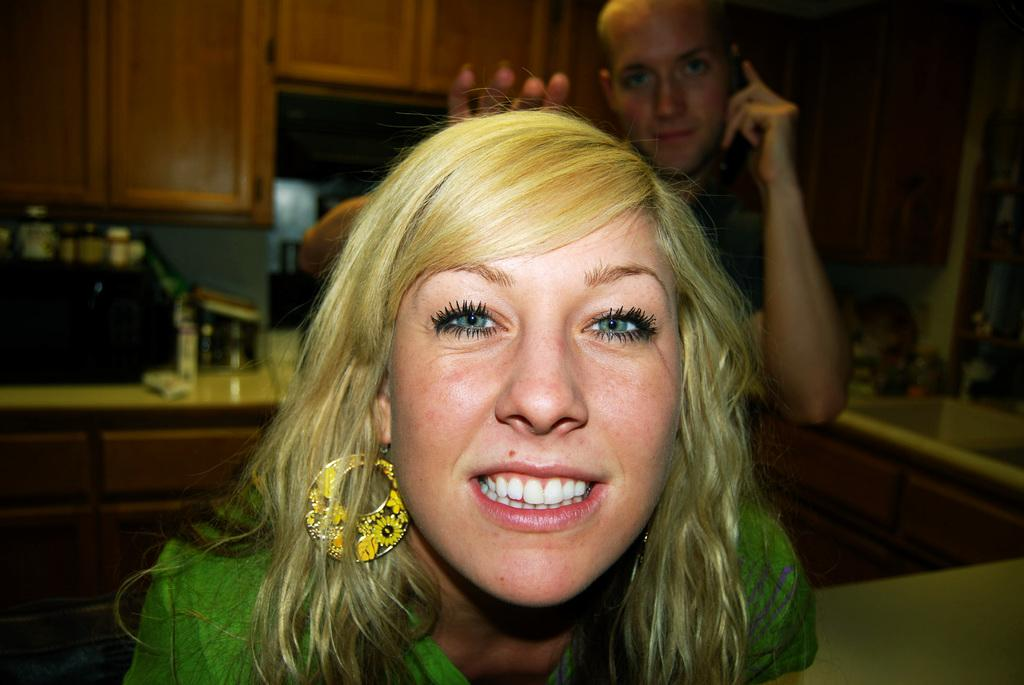Who is present in the image? There is a woman in the image. What is the woman doing in the image? The woman is smiling in the image. Can you describe the person behind the woman? There is a person standing behind the woman, but no specific details are provided. What can be seen in the background of the image? There are cupboards in the background of the image. What type of sign is the woman holding in the image? There is no sign present in the image; the woman is simply smiling. 